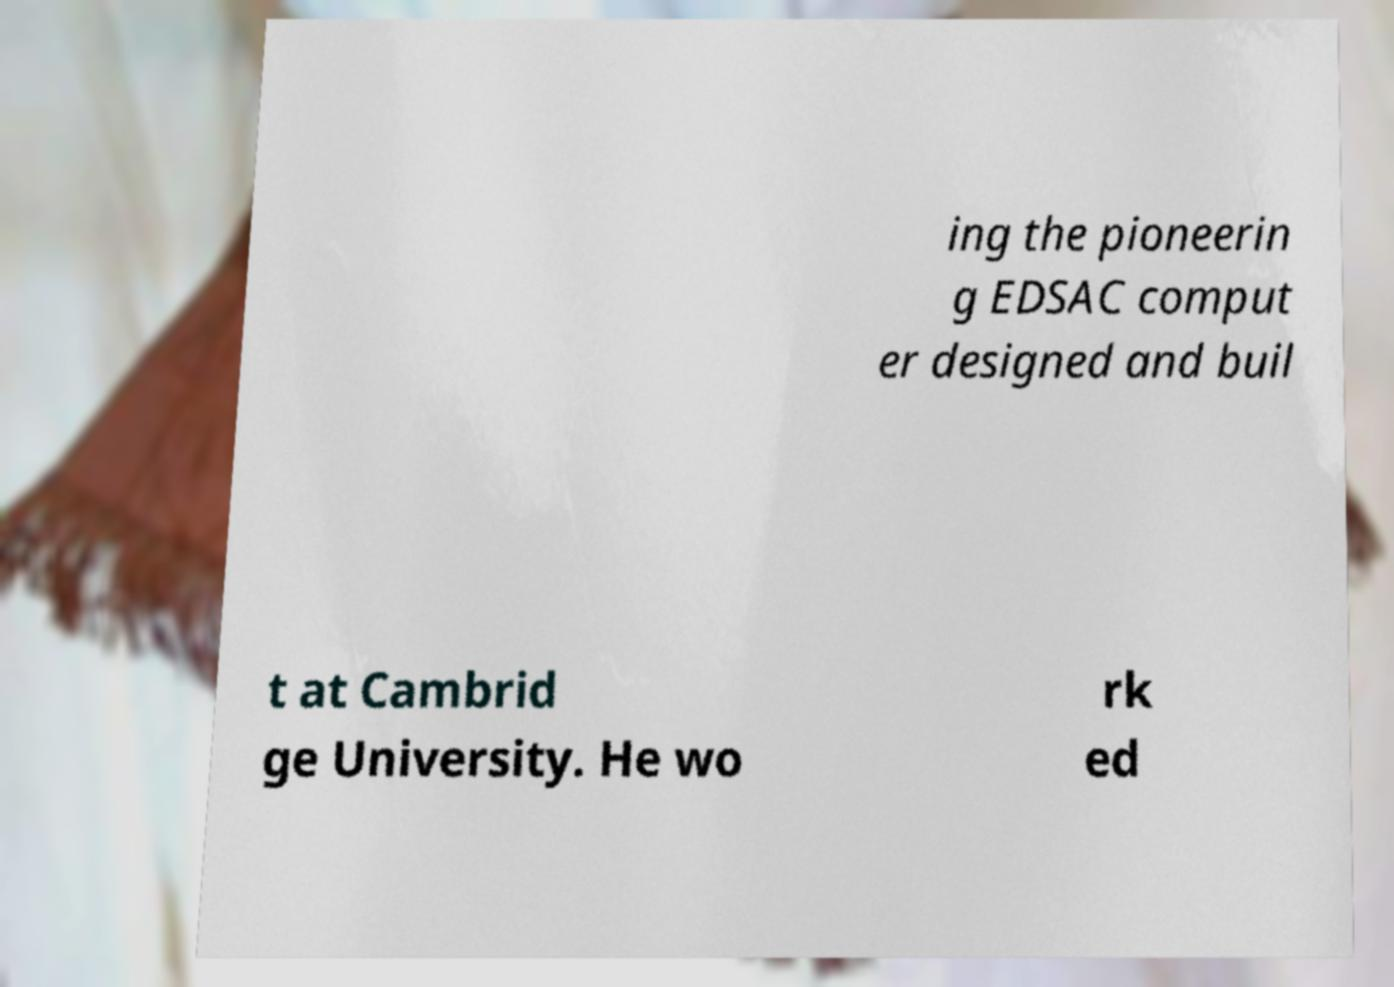Could you extract and type out the text from this image? ing the pioneerin g EDSAC comput er designed and buil t at Cambrid ge University. He wo rk ed 